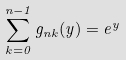<formula> <loc_0><loc_0><loc_500><loc_500>\sum _ { k = 0 } ^ { n - 1 } g _ { n k } ( y ) = e ^ { y }</formula> 